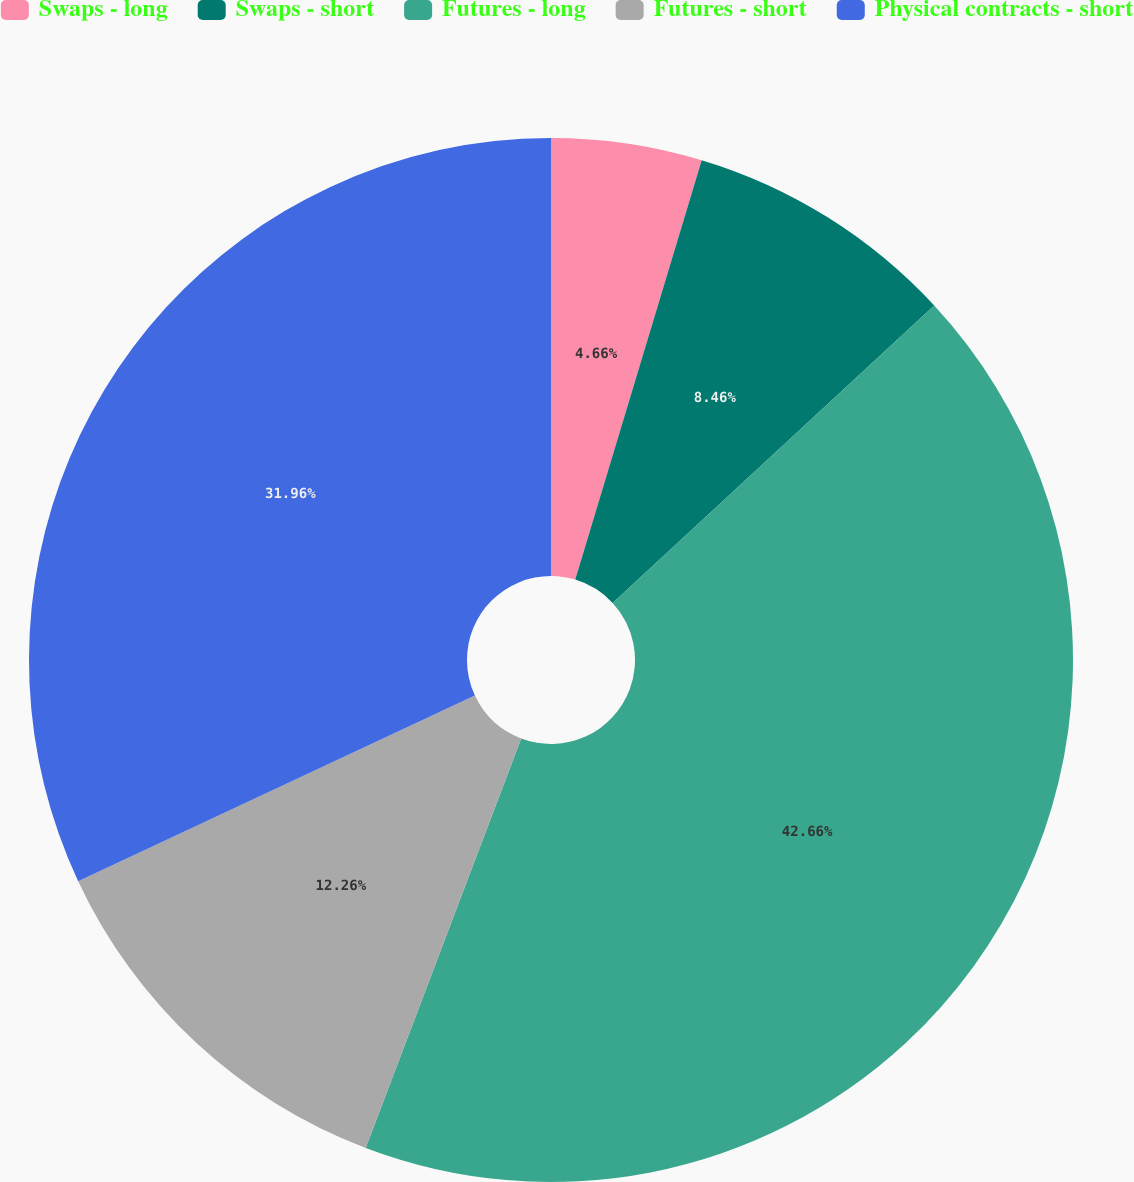Convert chart to OTSL. <chart><loc_0><loc_0><loc_500><loc_500><pie_chart><fcel>Swaps - long<fcel>Swaps - short<fcel>Futures - long<fcel>Futures - short<fcel>Physical contracts - short<nl><fcel>4.66%<fcel>8.46%<fcel>42.65%<fcel>12.26%<fcel>31.96%<nl></chart> 